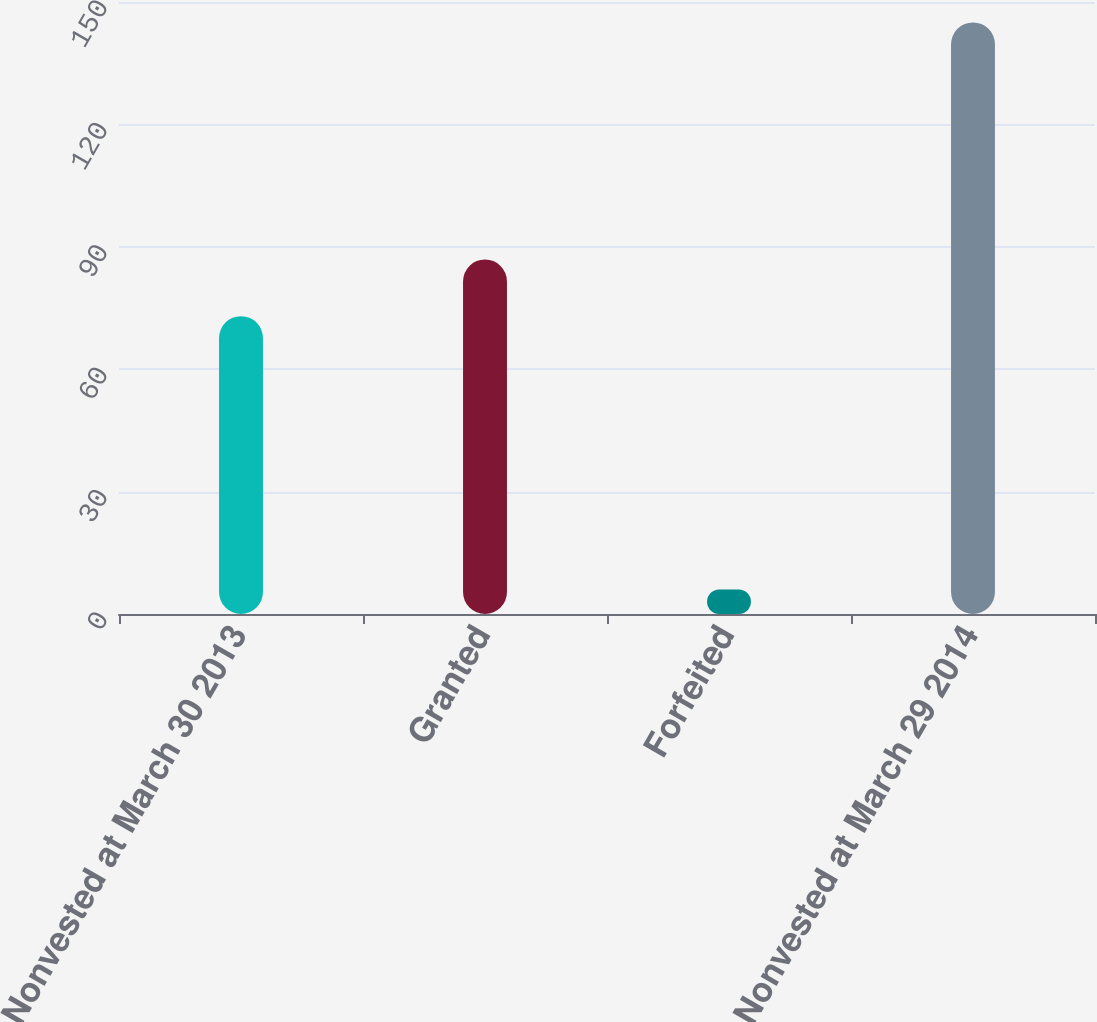<chart> <loc_0><loc_0><loc_500><loc_500><bar_chart><fcel>Nonvested at March 30 2013<fcel>Granted<fcel>Forfeited<fcel>Nonvested at March 29 2014<nl><fcel>73<fcel>86.9<fcel>6<fcel>145<nl></chart> 